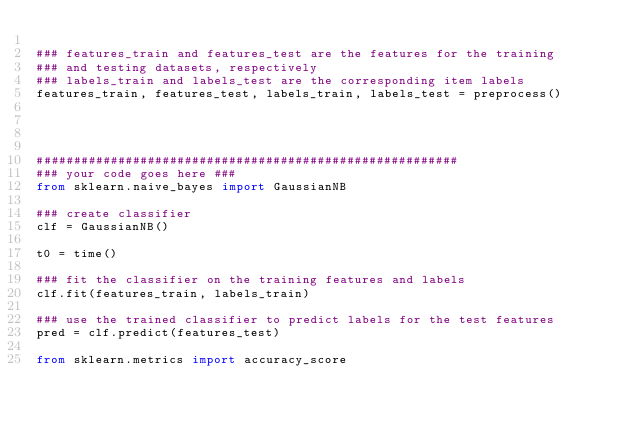Convert code to text. <code><loc_0><loc_0><loc_500><loc_500><_Python_>
### features_train and features_test are the features for the training
### and testing datasets, respectively
### labels_train and labels_test are the corresponding item labels
features_train, features_test, labels_train, labels_test = preprocess()




#########################################################
### your code goes here ###
from sklearn.naive_bayes import GaussianNB

### create classifier
clf = GaussianNB()

t0 = time()

### fit the classifier on the training features and labels
clf.fit(features_train, labels_train)

### use the trained classifier to predict labels for the test features
pred = clf.predict(features_test)

from sklearn.metrics import accuracy_score</code> 